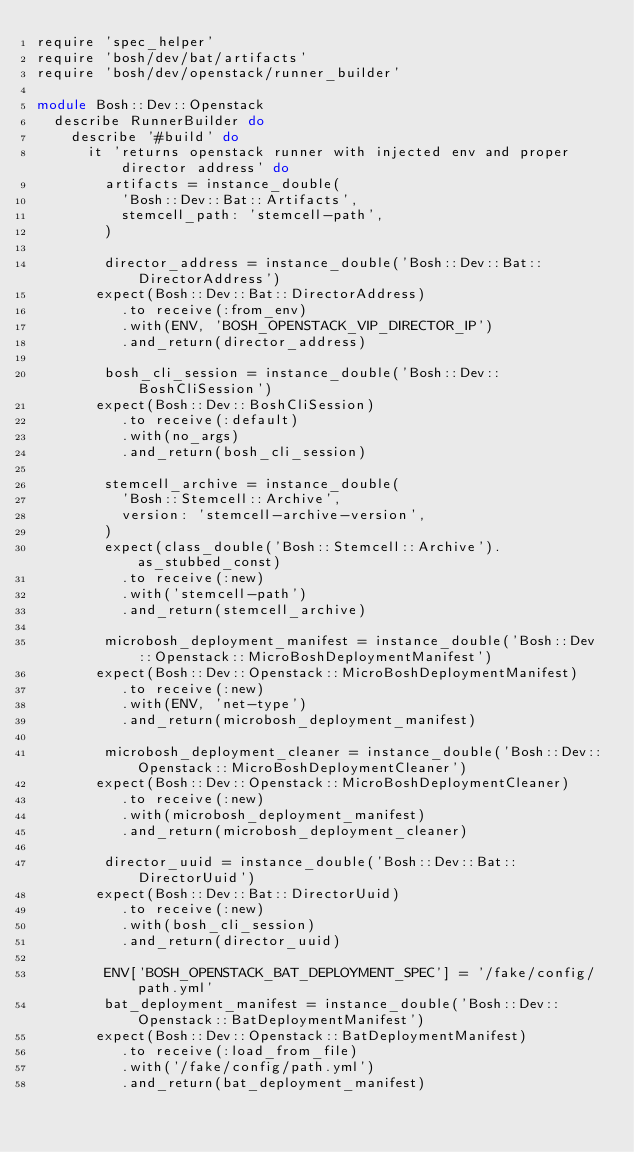<code> <loc_0><loc_0><loc_500><loc_500><_Ruby_>require 'spec_helper'
require 'bosh/dev/bat/artifacts'
require 'bosh/dev/openstack/runner_builder'

module Bosh::Dev::Openstack
  describe RunnerBuilder do
    describe '#build' do
      it 'returns openstack runner with injected env and proper director address' do
        artifacts = instance_double(
          'Bosh::Dev::Bat::Artifacts',
          stemcell_path: 'stemcell-path',
        )

        director_address = instance_double('Bosh::Dev::Bat::DirectorAddress')
       expect(Bosh::Dev::Bat::DirectorAddress)
          .to receive(:from_env)
          .with(ENV, 'BOSH_OPENSTACK_VIP_DIRECTOR_IP')
          .and_return(director_address)

        bosh_cli_session = instance_double('Bosh::Dev::BoshCliSession')
       expect(Bosh::Dev::BoshCliSession)
          .to receive(:default)
          .with(no_args)
          .and_return(bosh_cli_session)

        stemcell_archive = instance_double(
          'Bosh::Stemcell::Archive',
          version: 'stemcell-archive-version',
        )
        expect(class_double('Bosh::Stemcell::Archive').as_stubbed_const)
          .to receive(:new)
          .with('stemcell-path')
          .and_return(stemcell_archive)

        microbosh_deployment_manifest = instance_double('Bosh::Dev::Openstack::MicroBoshDeploymentManifest')
       expect(Bosh::Dev::Openstack::MicroBoshDeploymentManifest)
          .to receive(:new)
          .with(ENV, 'net-type')
          .and_return(microbosh_deployment_manifest)

        microbosh_deployment_cleaner = instance_double('Bosh::Dev::Openstack::MicroBoshDeploymentCleaner')
       expect(Bosh::Dev::Openstack::MicroBoshDeploymentCleaner)
          .to receive(:new)
          .with(microbosh_deployment_manifest)
          .and_return(microbosh_deployment_cleaner)

        director_uuid = instance_double('Bosh::Dev::Bat::DirectorUuid')
       expect(Bosh::Dev::Bat::DirectorUuid)
          .to receive(:new)
          .with(bosh_cli_session)
          .and_return(director_uuid)

        ENV['BOSH_OPENSTACK_BAT_DEPLOYMENT_SPEC'] = '/fake/config/path.yml'
        bat_deployment_manifest = instance_double('Bosh::Dev::Openstack::BatDeploymentManifest')
       expect(Bosh::Dev::Openstack::BatDeploymentManifest)
          .to receive(:load_from_file)
          .with('/fake/config/path.yml')
          .and_return(bat_deployment_manifest)
</code> 